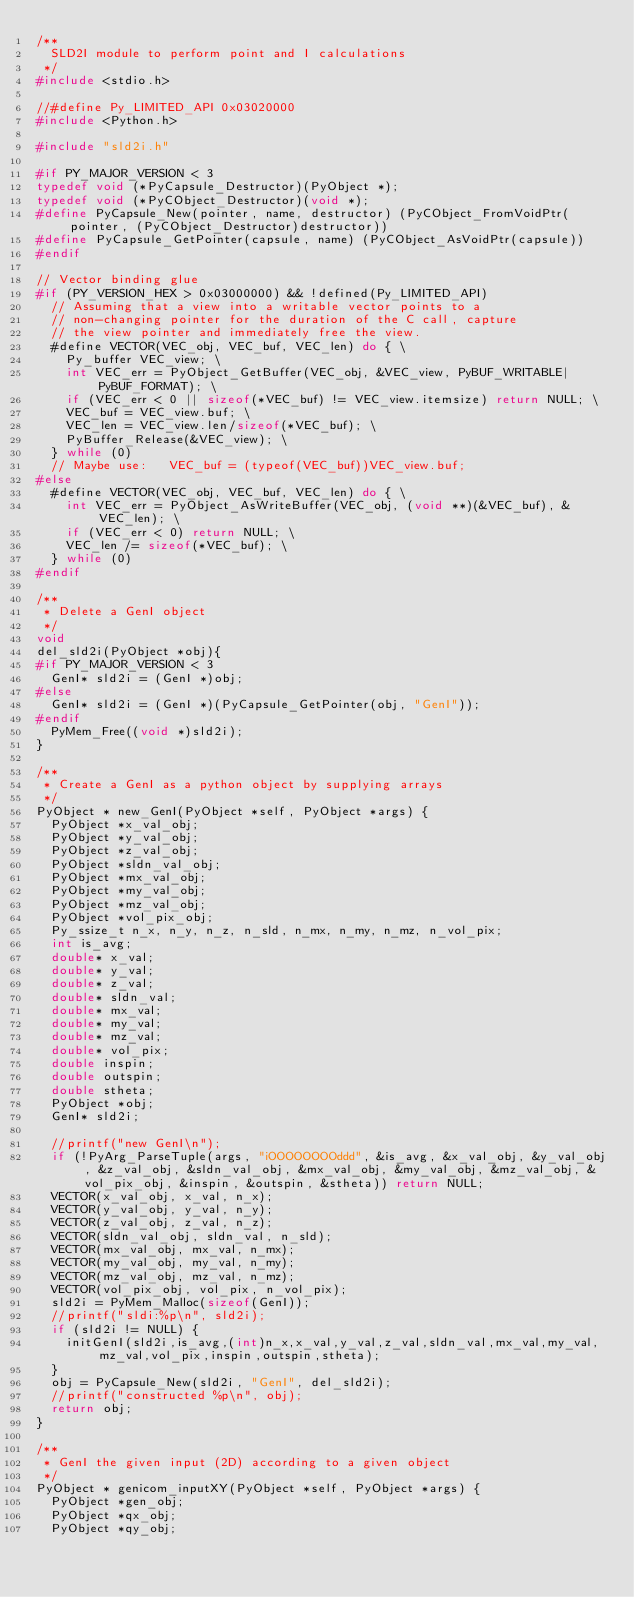<code> <loc_0><loc_0><loc_500><loc_500><_C_>/**
  SLD2I module to perform point and I calculations
 */
#include <stdio.h>

//#define Py_LIMITED_API 0x03020000
#include <Python.h>

#include "sld2i.h"

#if PY_MAJOR_VERSION < 3
typedef void (*PyCapsule_Destructor)(PyObject *);
typedef void (*PyCObject_Destructor)(void *);
#define PyCapsule_New(pointer, name, destructor) (PyCObject_FromVoidPtr(pointer, (PyCObject_Destructor)destructor))
#define PyCapsule_GetPointer(capsule, name) (PyCObject_AsVoidPtr(capsule))
#endif

// Vector binding glue
#if (PY_VERSION_HEX > 0x03000000) && !defined(Py_LIMITED_API)
  // Assuming that a view into a writable vector points to a
  // non-changing pointer for the duration of the C call, capture
  // the view pointer and immediately free the view.
  #define VECTOR(VEC_obj, VEC_buf, VEC_len) do { \
    Py_buffer VEC_view; \
    int VEC_err = PyObject_GetBuffer(VEC_obj, &VEC_view, PyBUF_WRITABLE|PyBUF_FORMAT); \
    if (VEC_err < 0 || sizeof(*VEC_buf) != VEC_view.itemsize) return NULL; \
    VEC_buf = VEC_view.buf; \
    VEC_len = VEC_view.len/sizeof(*VEC_buf); \
    PyBuffer_Release(&VEC_view); \
  } while (0)
  // Maybe use:   VEC_buf = (typeof(VEC_buf))VEC_view.buf;
#else
  #define VECTOR(VEC_obj, VEC_buf, VEC_len) do { \
    int VEC_err = PyObject_AsWriteBuffer(VEC_obj, (void **)(&VEC_buf), &VEC_len); \
    if (VEC_err < 0) return NULL; \
    VEC_len /= sizeof(*VEC_buf); \
  } while (0)
#endif

/**
 * Delete a GenI object
 */
void
del_sld2i(PyObject *obj){
#if PY_MAJOR_VERSION < 3
	GenI* sld2i = (GenI *)obj;
#else
	GenI* sld2i = (GenI *)(PyCapsule_GetPointer(obj, "GenI"));
#endif
	PyMem_Free((void *)sld2i);
}

/**
 * Create a GenI as a python object by supplying arrays
 */
PyObject * new_GenI(PyObject *self, PyObject *args) {
	PyObject *x_val_obj;
	PyObject *y_val_obj;
	PyObject *z_val_obj;
	PyObject *sldn_val_obj;
	PyObject *mx_val_obj;
	PyObject *my_val_obj;
	PyObject *mz_val_obj;
	PyObject *vol_pix_obj;
	Py_ssize_t n_x, n_y, n_z, n_sld, n_mx, n_my, n_mz, n_vol_pix;
	int is_avg;
	double* x_val;
	double* y_val;
	double* z_val;
	double* sldn_val;
	double* mx_val;
	double* my_val;
	double* mz_val;
	double* vol_pix;
	double inspin;
	double outspin;
	double stheta;
	PyObject *obj;
	GenI* sld2i;

	//printf("new GenI\n");
	if (!PyArg_ParseTuple(args, "iOOOOOOOOddd", &is_avg, &x_val_obj, &y_val_obj, &z_val_obj, &sldn_val_obj, &mx_val_obj, &my_val_obj, &mz_val_obj, &vol_pix_obj, &inspin, &outspin, &stheta)) return NULL;
	VECTOR(x_val_obj, x_val, n_x);
	VECTOR(y_val_obj, y_val, n_y);
	VECTOR(z_val_obj, z_val, n_z);
	VECTOR(sldn_val_obj, sldn_val, n_sld);
	VECTOR(mx_val_obj, mx_val, n_mx);
	VECTOR(my_val_obj, my_val, n_my);
	VECTOR(mz_val_obj, mz_val, n_mz);
	VECTOR(vol_pix_obj, vol_pix, n_vol_pix);
	sld2i = PyMem_Malloc(sizeof(GenI));
	//printf("sldi:%p\n", sld2i);
	if (sld2i != NULL) {
		initGenI(sld2i,is_avg,(int)n_x,x_val,y_val,z_val,sldn_val,mx_val,my_val,mz_val,vol_pix,inspin,outspin,stheta);
	}
	obj = PyCapsule_New(sld2i, "GenI", del_sld2i);
	//printf("constructed %p\n", obj);
	return obj;
}

/**
 * GenI the given input (2D) according to a given object
 */
PyObject * genicom_inputXY(PyObject *self, PyObject *args) {
	PyObject *gen_obj;
	PyObject *qx_obj;
	PyObject *qy_obj;</code> 